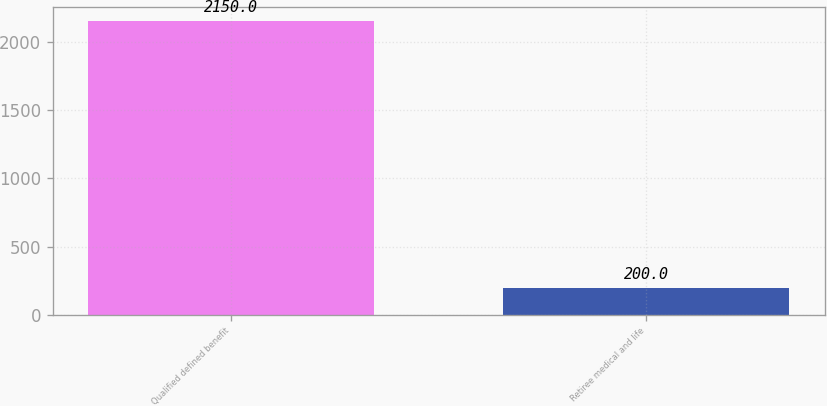Convert chart. <chart><loc_0><loc_0><loc_500><loc_500><bar_chart><fcel>Qualified defined benefit<fcel>Retiree medical and life<nl><fcel>2150<fcel>200<nl></chart> 